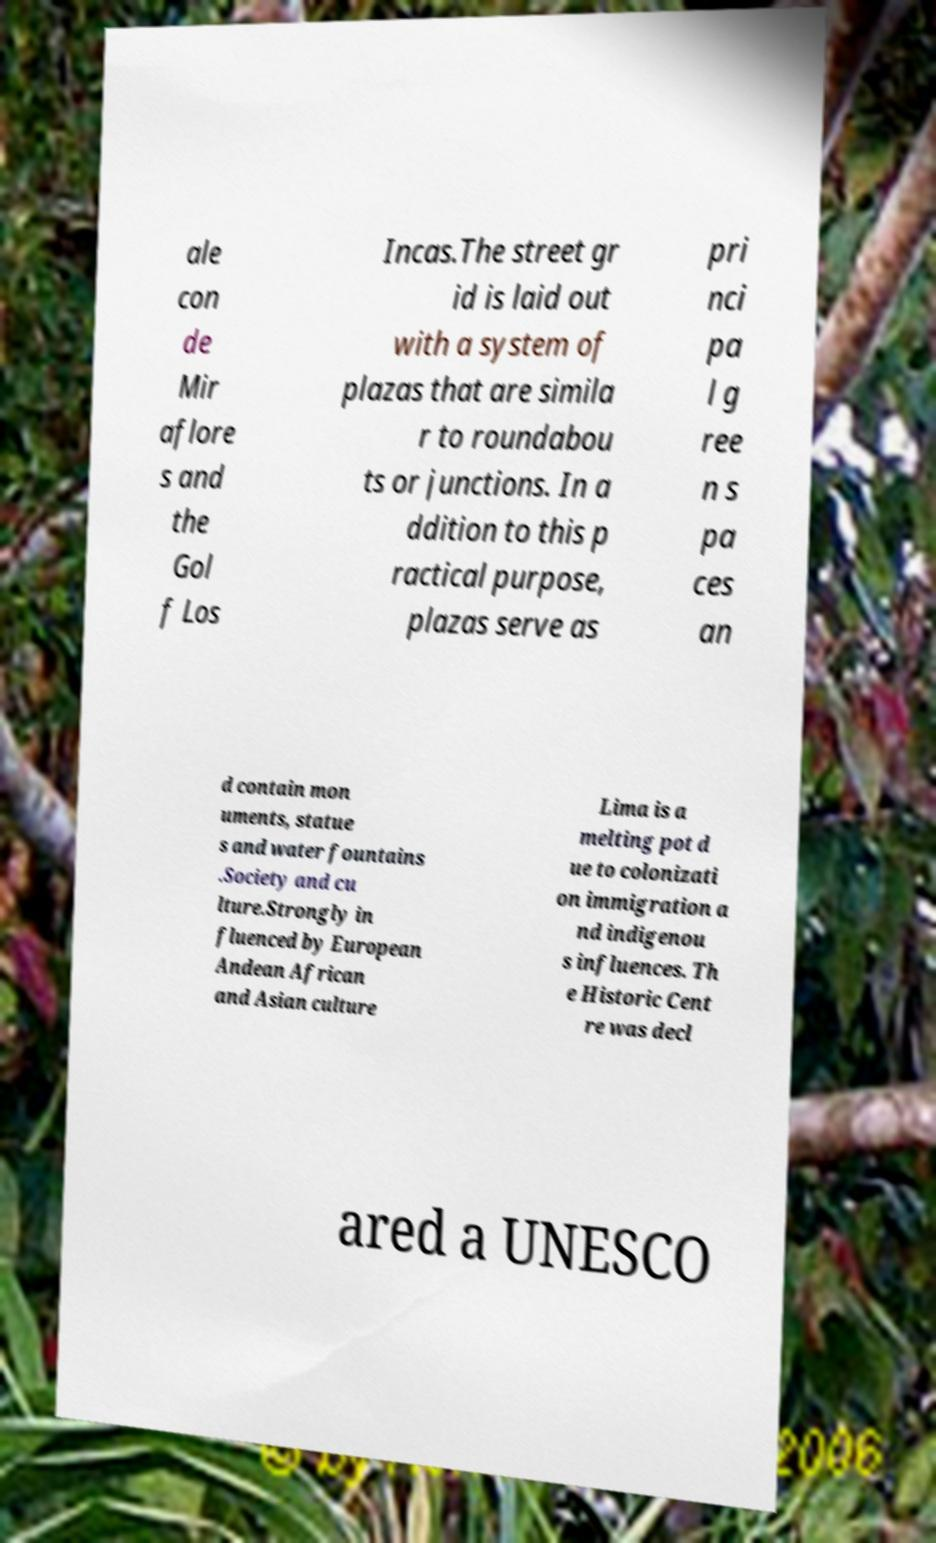Could you assist in decoding the text presented in this image and type it out clearly? ale con de Mir aflore s and the Gol f Los Incas.The street gr id is laid out with a system of plazas that are simila r to roundabou ts or junctions. In a ddition to this p ractical purpose, plazas serve as pri nci pa l g ree n s pa ces an d contain mon uments, statue s and water fountains .Society and cu lture.Strongly in fluenced by European Andean African and Asian culture Lima is a melting pot d ue to colonizati on immigration a nd indigenou s influences. Th e Historic Cent re was decl ared a UNESCO 